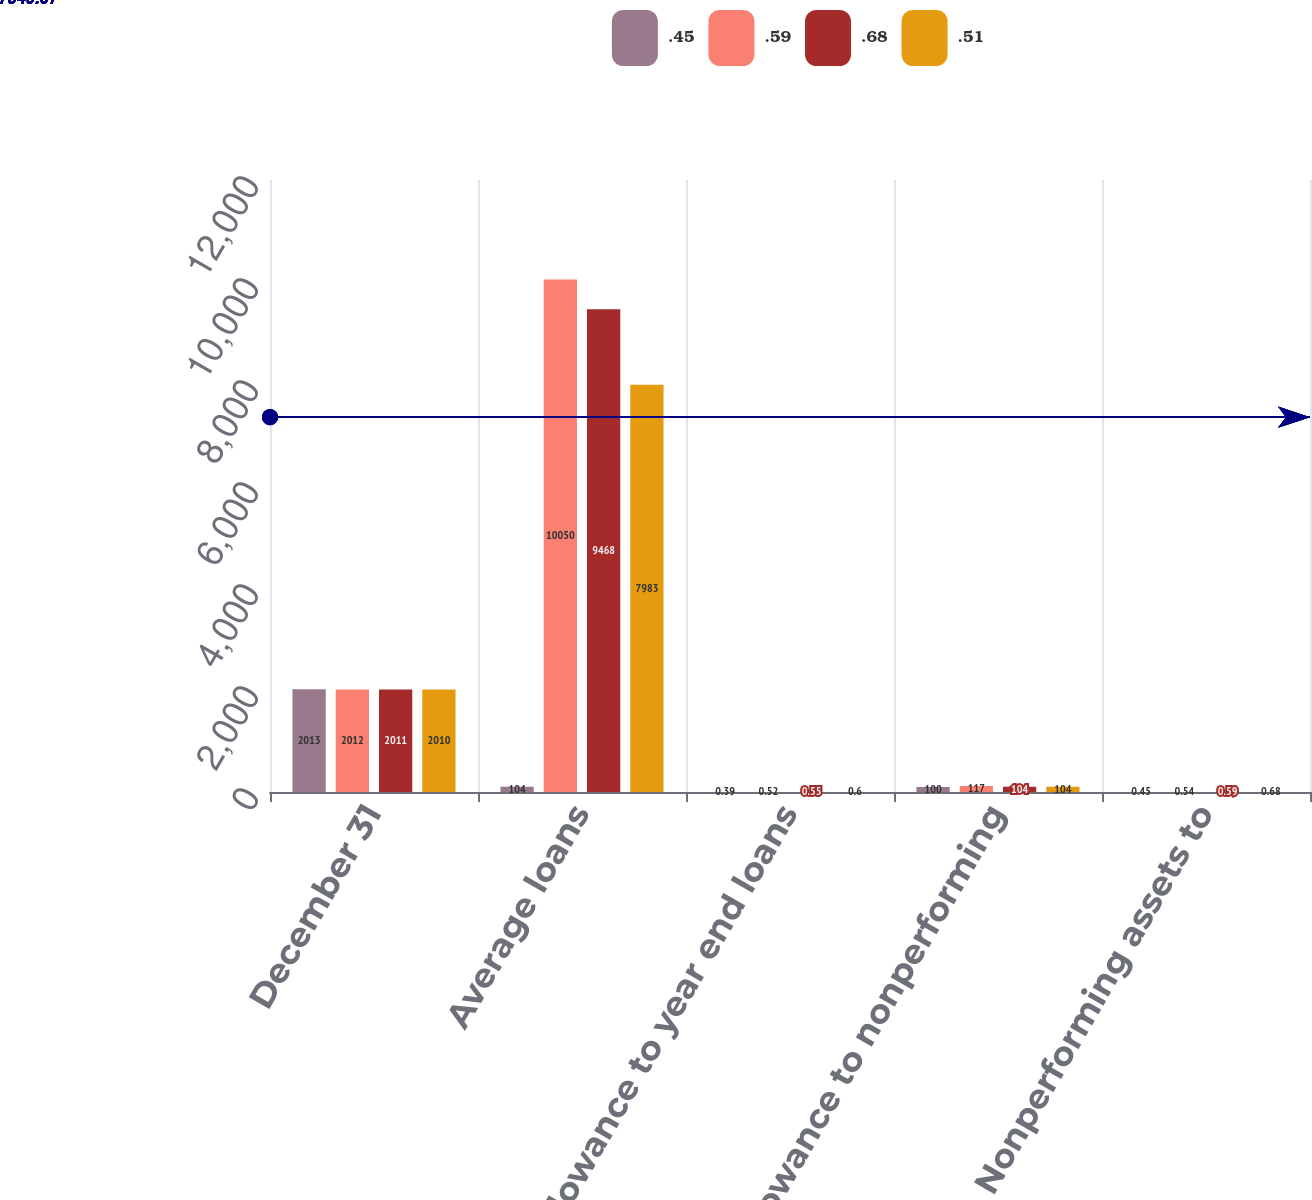Convert chart to OTSL. <chart><loc_0><loc_0><loc_500><loc_500><stacked_bar_chart><ecel><fcel>December 31<fcel>Average loans<fcel>Allowance to year end loans<fcel>Allowance to nonperforming<fcel>Nonperforming assets to<nl><fcel>0.45<fcel>2013<fcel>104<fcel>0.39<fcel>100<fcel>0.45<nl><fcel>0.59<fcel>2012<fcel>10050<fcel>0.52<fcel>117<fcel>0.54<nl><fcel>0.68<fcel>2011<fcel>9468<fcel>0.55<fcel>104<fcel>0.59<nl><fcel>0.51<fcel>2010<fcel>7983<fcel>0.6<fcel>104<fcel>0.68<nl></chart> 